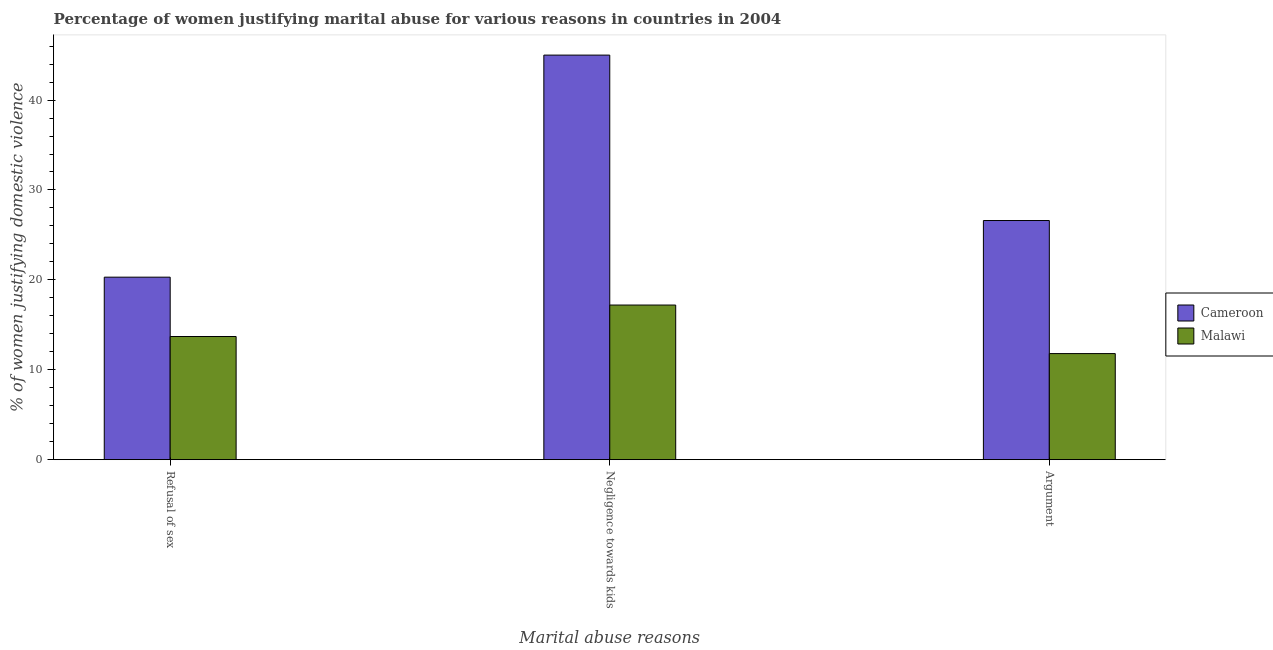How many groups of bars are there?
Offer a terse response. 3. Are the number of bars on each tick of the X-axis equal?
Offer a very short reply. Yes. How many bars are there on the 2nd tick from the left?
Your answer should be very brief. 2. What is the label of the 2nd group of bars from the left?
Keep it short and to the point. Negligence towards kids. What is the percentage of women justifying domestic violence due to arguments in Cameroon?
Give a very brief answer. 26.6. Across all countries, what is the maximum percentage of women justifying domestic violence due to arguments?
Offer a terse response. 26.6. Across all countries, what is the minimum percentage of women justifying domestic violence due to refusal of sex?
Provide a succinct answer. 13.7. In which country was the percentage of women justifying domestic violence due to negligence towards kids maximum?
Offer a terse response. Cameroon. In which country was the percentage of women justifying domestic violence due to arguments minimum?
Offer a very short reply. Malawi. What is the total percentage of women justifying domestic violence due to refusal of sex in the graph?
Offer a very short reply. 34. What is the difference between the percentage of women justifying domestic violence due to arguments in Malawi and that in Cameroon?
Your response must be concise. -14.8. What is the difference between the percentage of women justifying domestic violence due to arguments in Malawi and the percentage of women justifying domestic violence due to negligence towards kids in Cameroon?
Offer a very short reply. -33.2. What is the average percentage of women justifying domestic violence due to negligence towards kids per country?
Your response must be concise. 31.1. What is the difference between the percentage of women justifying domestic violence due to refusal of sex and percentage of women justifying domestic violence due to negligence towards kids in Malawi?
Ensure brevity in your answer.  -3.5. What is the ratio of the percentage of women justifying domestic violence due to arguments in Cameroon to that in Malawi?
Offer a terse response. 2.25. Is the percentage of women justifying domestic violence due to negligence towards kids in Cameroon less than that in Malawi?
Offer a terse response. No. What is the difference between the highest and the second highest percentage of women justifying domestic violence due to refusal of sex?
Your response must be concise. 6.6. What does the 2nd bar from the left in Argument represents?
Ensure brevity in your answer.  Malawi. What does the 1st bar from the right in Refusal of sex represents?
Offer a very short reply. Malawi. Is it the case that in every country, the sum of the percentage of women justifying domestic violence due to refusal of sex and percentage of women justifying domestic violence due to negligence towards kids is greater than the percentage of women justifying domestic violence due to arguments?
Provide a short and direct response. Yes. Are the values on the major ticks of Y-axis written in scientific E-notation?
Ensure brevity in your answer.  No. Does the graph contain any zero values?
Offer a terse response. No. Where does the legend appear in the graph?
Make the answer very short. Center right. How many legend labels are there?
Ensure brevity in your answer.  2. What is the title of the graph?
Offer a very short reply. Percentage of women justifying marital abuse for various reasons in countries in 2004. What is the label or title of the X-axis?
Your answer should be compact. Marital abuse reasons. What is the label or title of the Y-axis?
Make the answer very short. % of women justifying domestic violence. What is the % of women justifying domestic violence of Cameroon in Refusal of sex?
Keep it short and to the point. 20.3. What is the % of women justifying domestic violence in Cameroon in Negligence towards kids?
Ensure brevity in your answer.  45. What is the % of women justifying domestic violence in Cameroon in Argument?
Ensure brevity in your answer.  26.6. Across all Marital abuse reasons, what is the maximum % of women justifying domestic violence in Malawi?
Give a very brief answer. 17.2. Across all Marital abuse reasons, what is the minimum % of women justifying domestic violence of Cameroon?
Ensure brevity in your answer.  20.3. What is the total % of women justifying domestic violence of Cameroon in the graph?
Your response must be concise. 91.9. What is the total % of women justifying domestic violence in Malawi in the graph?
Keep it short and to the point. 42.7. What is the difference between the % of women justifying domestic violence in Cameroon in Refusal of sex and that in Negligence towards kids?
Ensure brevity in your answer.  -24.7. What is the difference between the % of women justifying domestic violence of Malawi in Refusal of sex and that in Negligence towards kids?
Your answer should be very brief. -3.5. What is the difference between the % of women justifying domestic violence of Cameroon in Refusal of sex and that in Argument?
Make the answer very short. -6.3. What is the difference between the % of women justifying domestic violence in Malawi in Refusal of sex and that in Argument?
Your response must be concise. 1.9. What is the difference between the % of women justifying domestic violence of Cameroon in Negligence towards kids and that in Argument?
Make the answer very short. 18.4. What is the difference between the % of women justifying domestic violence in Cameroon in Refusal of sex and the % of women justifying domestic violence in Malawi in Argument?
Make the answer very short. 8.5. What is the difference between the % of women justifying domestic violence in Cameroon in Negligence towards kids and the % of women justifying domestic violence in Malawi in Argument?
Provide a succinct answer. 33.2. What is the average % of women justifying domestic violence in Cameroon per Marital abuse reasons?
Make the answer very short. 30.63. What is the average % of women justifying domestic violence of Malawi per Marital abuse reasons?
Provide a succinct answer. 14.23. What is the difference between the % of women justifying domestic violence of Cameroon and % of women justifying domestic violence of Malawi in Refusal of sex?
Your response must be concise. 6.6. What is the difference between the % of women justifying domestic violence of Cameroon and % of women justifying domestic violence of Malawi in Negligence towards kids?
Provide a succinct answer. 27.8. What is the ratio of the % of women justifying domestic violence of Cameroon in Refusal of sex to that in Negligence towards kids?
Provide a short and direct response. 0.45. What is the ratio of the % of women justifying domestic violence of Malawi in Refusal of sex to that in Negligence towards kids?
Your answer should be very brief. 0.8. What is the ratio of the % of women justifying domestic violence of Cameroon in Refusal of sex to that in Argument?
Provide a short and direct response. 0.76. What is the ratio of the % of women justifying domestic violence of Malawi in Refusal of sex to that in Argument?
Provide a short and direct response. 1.16. What is the ratio of the % of women justifying domestic violence of Cameroon in Negligence towards kids to that in Argument?
Offer a very short reply. 1.69. What is the ratio of the % of women justifying domestic violence in Malawi in Negligence towards kids to that in Argument?
Your answer should be compact. 1.46. What is the difference between the highest and the second highest % of women justifying domestic violence in Cameroon?
Provide a short and direct response. 18.4. What is the difference between the highest and the lowest % of women justifying domestic violence in Cameroon?
Ensure brevity in your answer.  24.7. What is the difference between the highest and the lowest % of women justifying domestic violence of Malawi?
Make the answer very short. 5.4. 